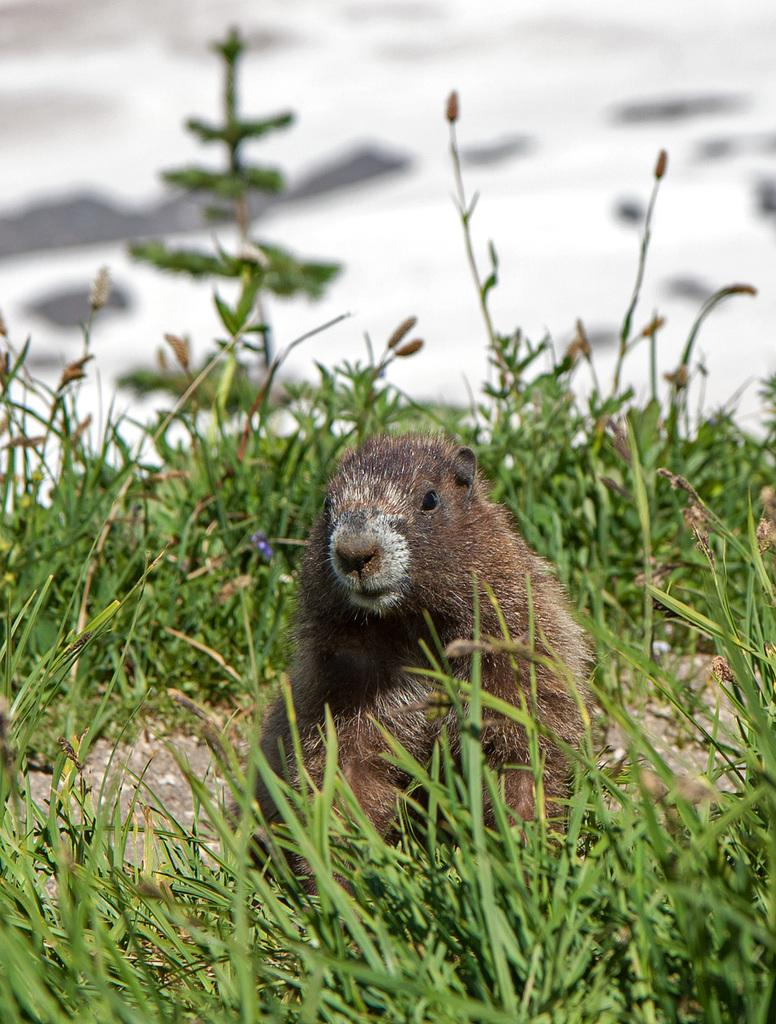What type of vegetation is present in the image? The image contains grass. What is the color of the grass? The grass is green in color. What else can be seen in the image besides the grass? There is an animal in the image. Where is the animal located in the image? The animal is in the middle of the image. What is the color of the animal? The animal is brown in color. What type of butter is being used by the animal in the image? There is no butter present in the image, and the animal is not using any butter. 